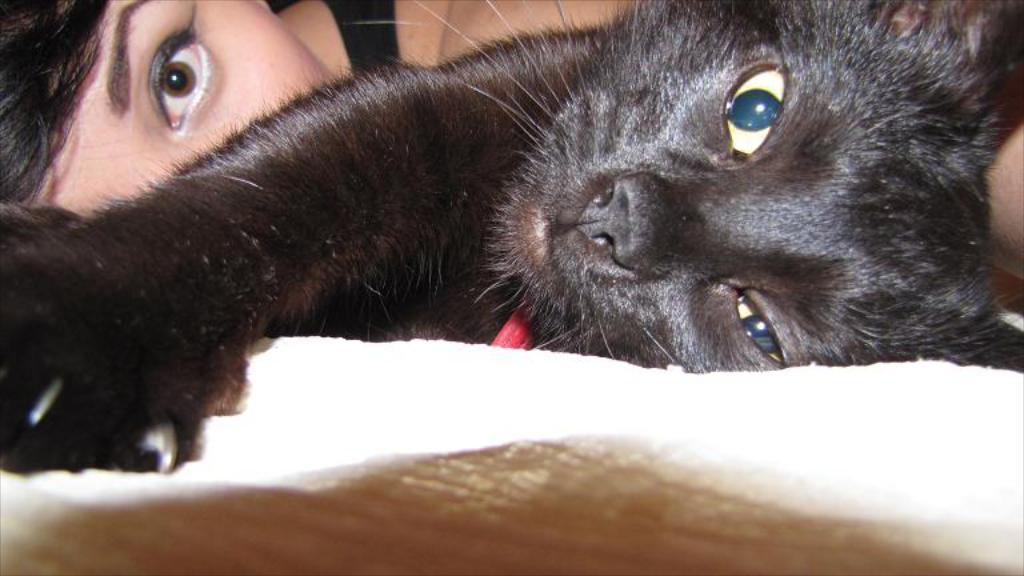Who is present in the image? There is a woman in the image. What type of animal is also present in the image? There is a cat in the image. What is the current temperature in the image? The image does not provide information about the current temperature. What type of game is being played in the image? There is no game, such as chess, being played in the image. Is there a ghost visible in the image? There is no ghost present in the image. 